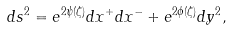<formula> <loc_0><loc_0><loc_500><loc_500>d s ^ { 2 } = e ^ { 2 \psi ( \zeta ) } d x ^ { + } d x ^ { - } + e ^ { 2 \phi ( \zeta ) } d y ^ { 2 } ,</formula> 